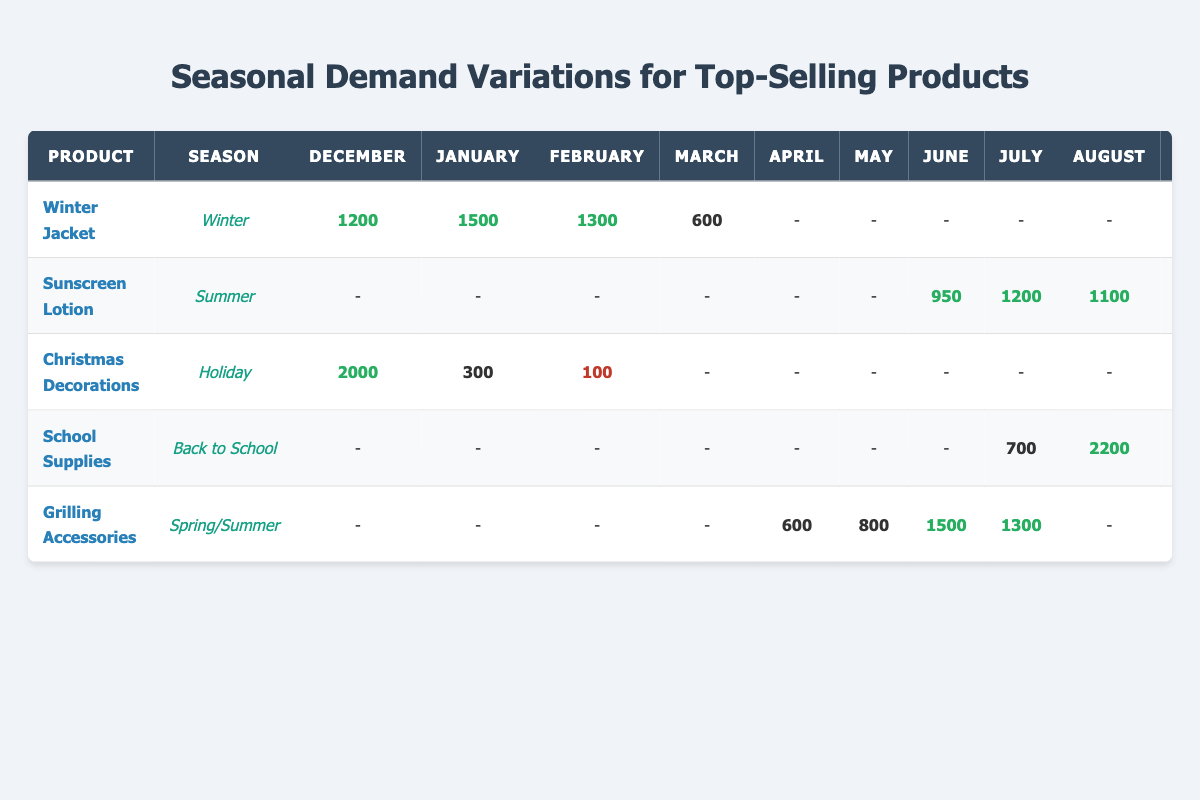What is the average monthly sales for Winter Jackets during January? The table indicates that the sales figure for Winter Jackets in January is 1500 units. Therefore, the average monthly sales for Winter Jackets during January is simply this value.
Answer: 1500 Which product has the highest sales in December? Looking at the table for December sales, Christmas Decorations have the highest sales at 2000 units. Comparing all products shows that Christmas Decorations is the only product reaching that sales figure.
Answer: Christmas Decorations In which month does School Supplies have the lowest sales? The sales figures for School Supplies are 700 in July, 2200 in August, 1500 in September, and 400 in October. Among these, October shows the lowest sales of 400 units.
Answer: October Is the average sales for Sunscreen Lotion highest in July compared to other summer months? The average sales for Sunscreen Lotion in summer months are 950 in June, 1200 in July, 1100 in August, and 300 in September. July has 1200, which is higher than June and August. Therefore, July has the highest sales when compared to summer months.
Answer: Yes How many units of Christmas Decorations are sold in total from November to February? The table shows that in November, sales are 800; in December, they are 2000; in January, they are 300; and in February, they are 100. Summing these figures (800 + 2000 + 300 + 100) yields 3200 units sold across these months.
Answer: 3200 What is the percentage decrease in average monthly sales for Grilling Accessories from May to June? For Grilling Accessories, the average sales are 800 in May and 1500 in June. To find the percentage decrease, first find the difference (800 - 1500 = -700), which indicates an increase instead. The formula for percentage change is (New Value - Old Value) / Old Value * 100. Applying this: (1500 - 800) / 800 * 100 = 87.5%.
Answer: 87.5% Do Grilling Accessories sell higher in June than Winter Jackets in the same month? The table shows that Grilling Accessories sell 1500 units in June while Winter Jackets are not sold at all in June (indicated by "-"). Therefore, the sales for Grilling Accessories exceed those of Winter Jackets in this month.
Answer: Yes What is the total sales for School Supplies from July to September? The sales for School Supplies show 700 in July, 2200 in August, and 1500 in September. Adding these figures together (700 + 2200 + 1500) equals 4400 units sold from July to September.
Answer: 4400 